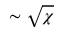Convert formula to latex. <formula><loc_0><loc_0><loc_500><loc_500>\sim \sqrt { \chi }</formula> 